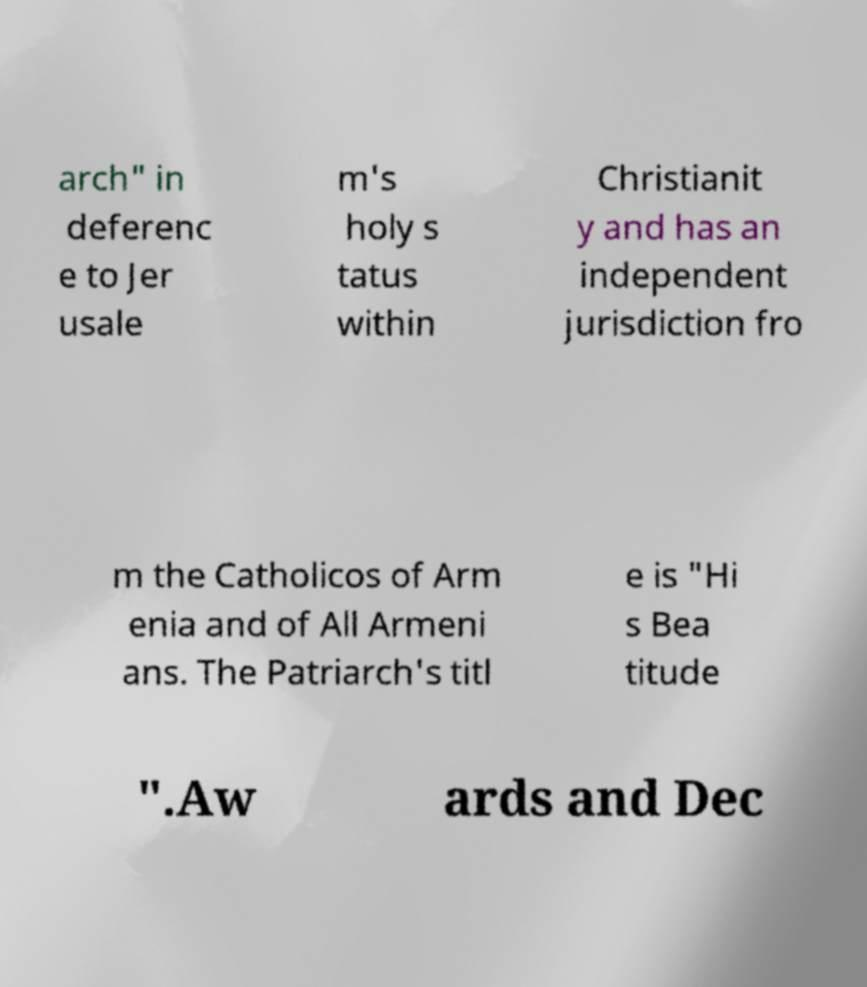I need the written content from this picture converted into text. Can you do that? arch" in deferenc e to Jer usale m's holy s tatus within Christianit y and has an independent jurisdiction fro m the Catholicos of Arm enia and of All Armeni ans. The Patriarch's titl e is "Hi s Bea titude ".Aw ards and Dec 